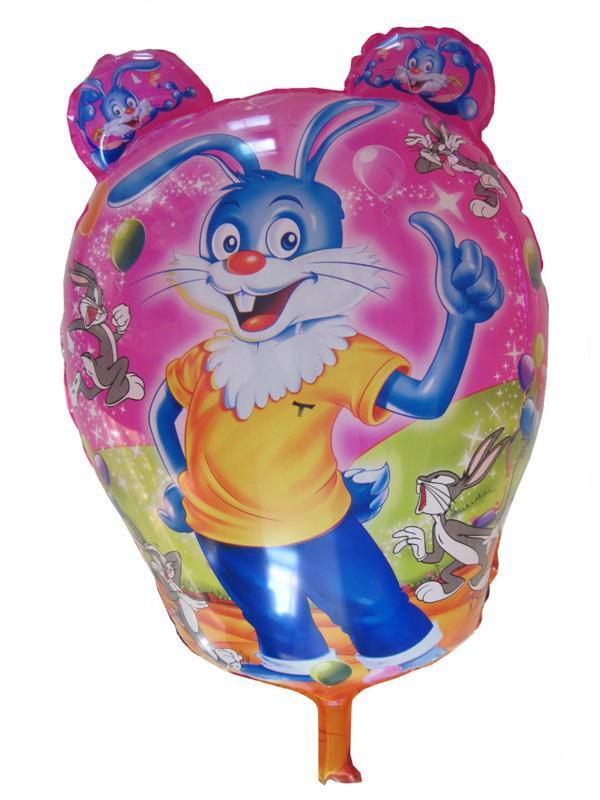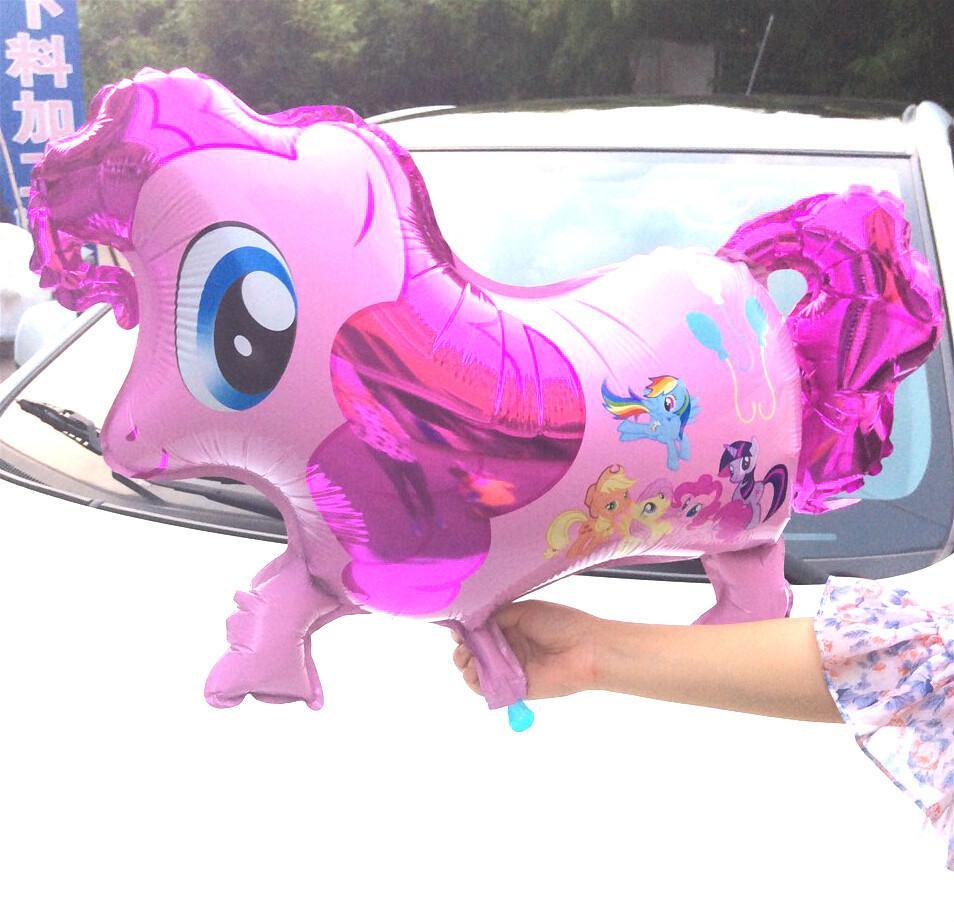The first image is the image on the left, the second image is the image on the right. For the images shown, is this caption "There are no less than five balloons" true? Answer yes or no. No. 